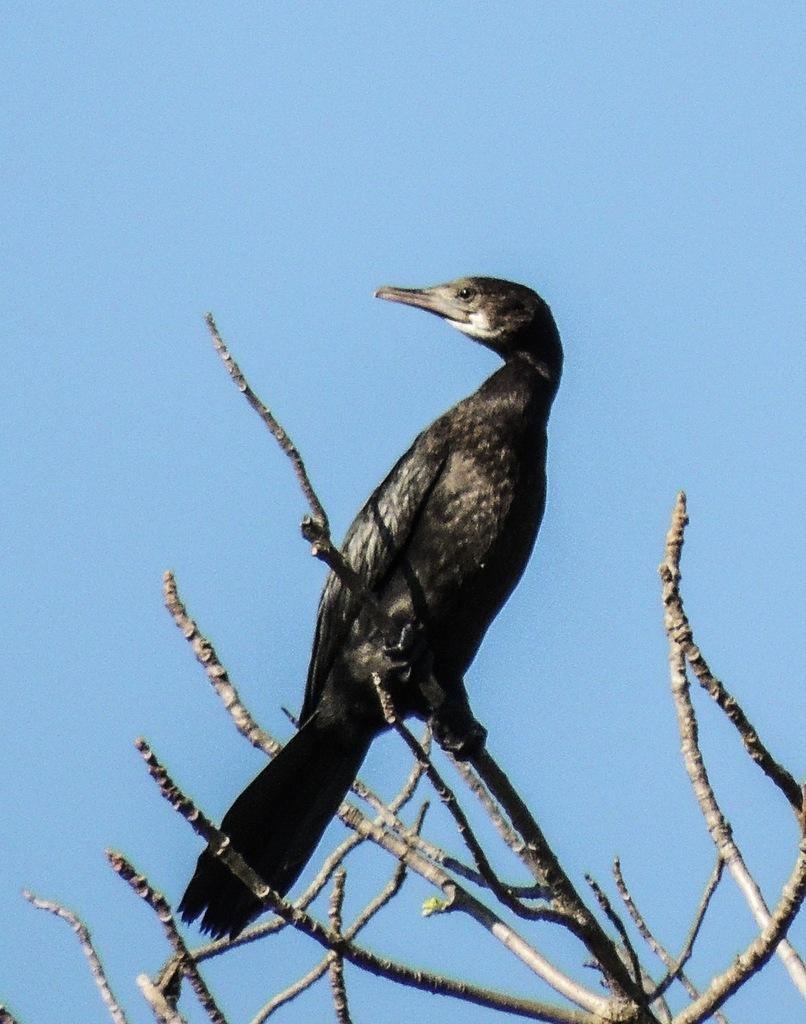What animal can be seen in the image? There is a bird on a tree in the image. What is visible in the background of the image? The sky is visible in the background of the image. What type of yarn is the bird using to weave a nest in the image? There is no yarn present in the image, and the bird is not shown weaving a nest. 